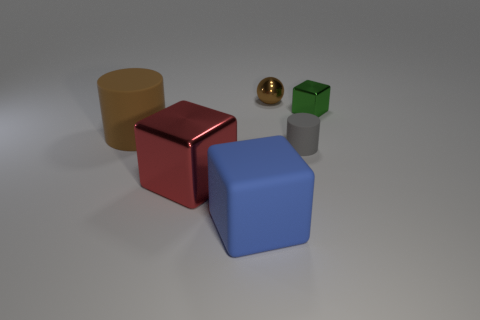Subtract all large blocks. How many blocks are left? 1 Add 2 red cubes. How many objects exist? 8 Subtract all balls. How many objects are left? 5 Add 5 brown cylinders. How many brown cylinders are left? 6 Add 5 gray matte cylinders. How many gray matte cylinders exist? 6 Subtract 0 cyan cylinders. How many objects are left? 6 Subtract all big brown things. Subtract all big brown things. How many objects are left? 4 